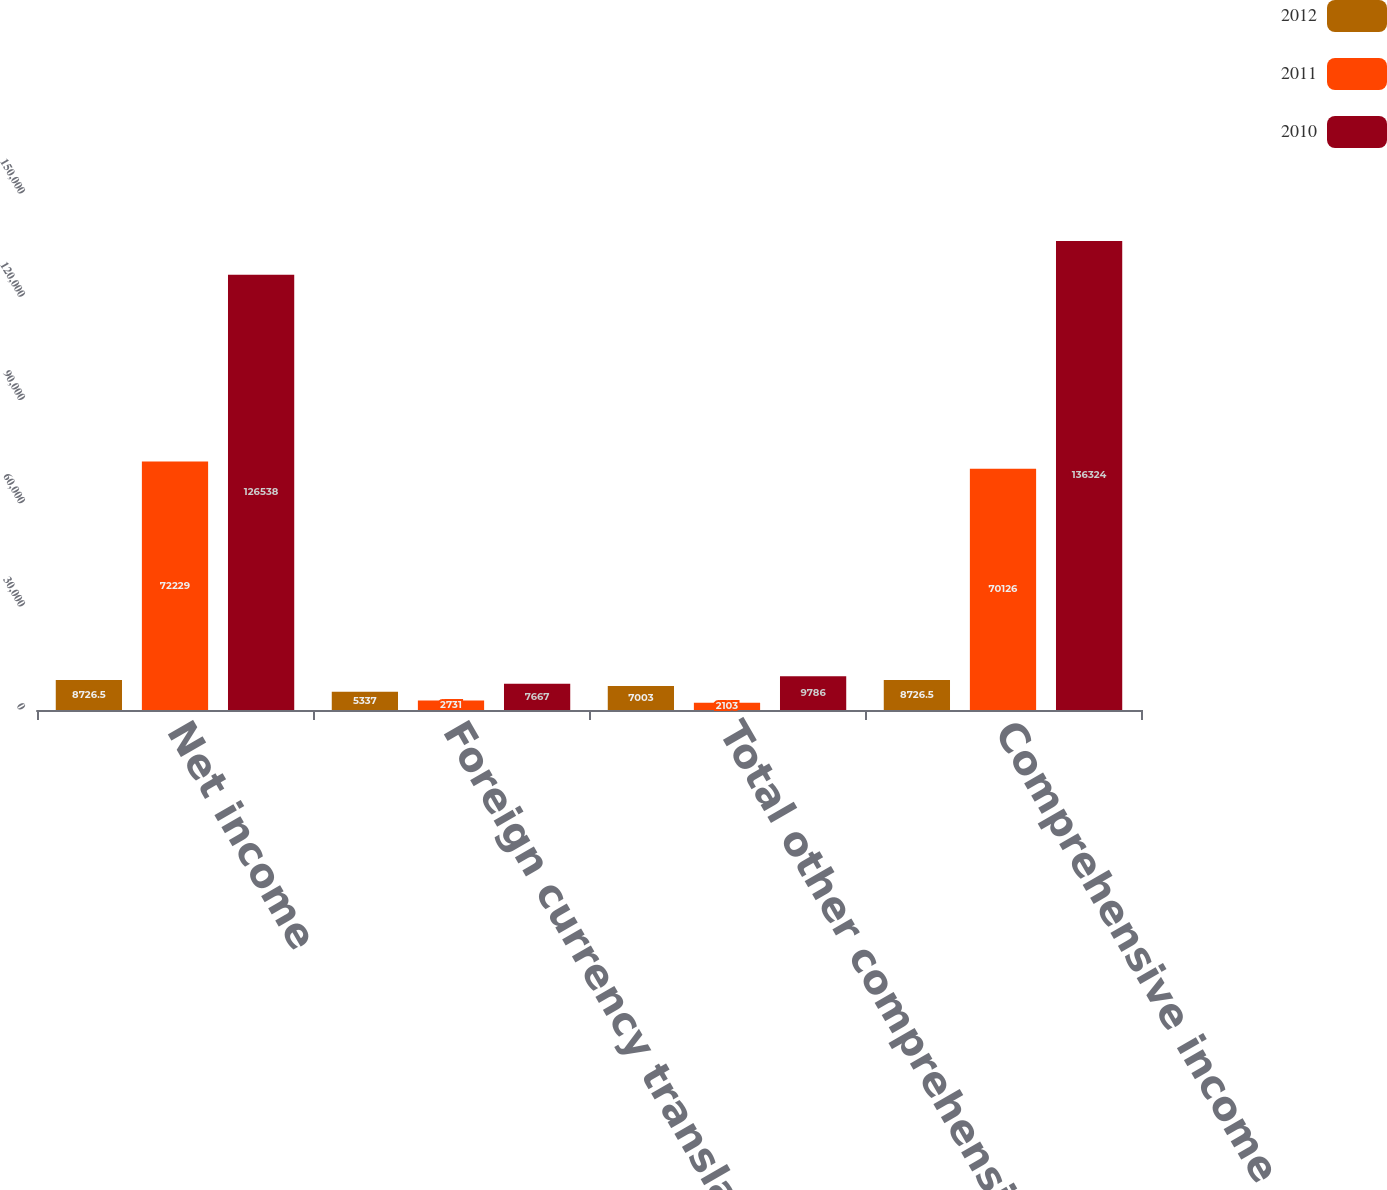<chart> <loc_0><loc_0><loc_500><loc_500><stacked_bar_chart><ecel><fcel>Net income<fcel>Foreign currency translation<fcel>Total other comprehensive<fcel>Comprehensive income<nl><fcel>2012<fcel>8726.5<fcel>5337<fcel>7003<fcel>8726.5<nl><fcel>2011<fcel>72229<fcel>2731<fcel>2103<fcel>70126<nl><fcel>2010<fcel>126538<fcel>7667<fcel>9786<fcel>136324<nl></chart> 